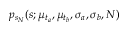<formula> <loc_0><loc_0><loc_500><loc_500>p _ { s _ { N } } ( s ; \mu _ { t _ { a } } , \mu _ { t _ { b } } , \sigma _ { a } , \sigma _ { b } , N )</formula> 